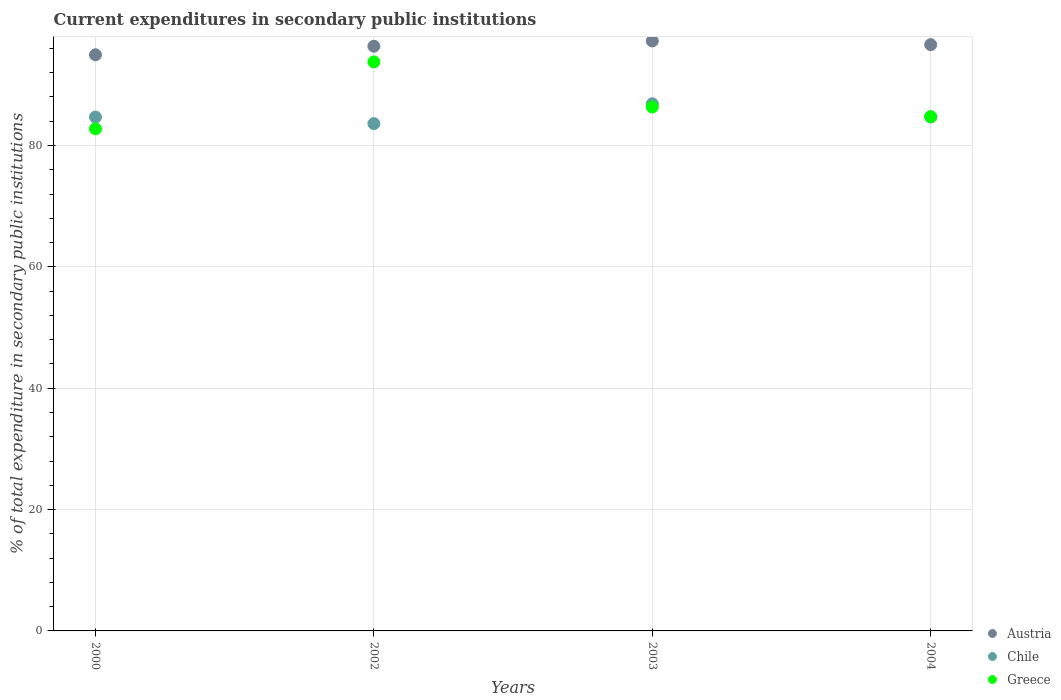Is the number of dotlines equal to the number of legend labels?
Offer a very short reply. Yes. What is the current expenditures in secondary public institutions in Greece in 2004?
Provide a succinct answer. 84.74. Across all years, what is the maximum current expenditures in secondary public institutions in Austria?
Provide a succinct answer. 97.22. Across all years, what is the minimum current expenditures in secondary public institutions in Austria?
Your answer should be compact. 94.94. In which year was the current expenditures in secondary public institutions in Greece maximum?
Your answer should be compact. 2002. In which year was the current expenditures in secondary public institutions in Chile minimum?
Provide a succinct answer. 2002. What is the total current expenditures in secondary public institutions in Greece in the graph?
Provide a succinct answer. 347.6. What is the difference between the current expenditures in secondary public institutions in Greece in 2003 and that in 2004?
Offer a terse response. 1.59. What is the difference between the current expenditures in secondary public institutions in Greece in 2004 and the current expenditures in secondary public institutions in Austria in 2003?
Offer a terse response. -12.48. What is the average current expenditures in secondary public institutions in Greece per year?
Make the answer very short. 86.9. In the year 2004, what is the difference between the current expenditures in secondary public institutions in Austria and current expenditures in secondary public institutions in Greece?
Give a very brief answer. 11.87. What is the ratio of the current expenditures in secondary public institutions in Chile in 2000 to that in 2003?
Your answer should be very brief. 0.97. What is the difference between the highest and the second highest current expenditures in secondary public institutions in Chile?
Ensure brevity in your answer.  2.17. What is the difference between the highest and the lowest current expenditures in secondary public institutions in Greece?
Ensure brevity in your answer.  11.03. Is the sum of the current expenditures in secondary public institutions in Austria in 2003 and 2004 greater than the maximum current expenditures in secondary public institutions in Chile across all years?
Provide a succinct answer. Yes. Does the current expenditures in secondary public institutions in Greece monotonically increase over the years?
Provide a succinct answer. No. Is the current expenditures in secondary public institutions in Chile strictly greater than the current expenditures in secondary public institutions in Greece over the years?
Provide a succinct answer. No. Is the current expenditures in secondary public institutions in Chile strictly less than the current expenditures in secondary public institutions in Greece over the years?
Offer a very short reply. No. How many dotlines are there?
Provide a succinct answer. 3. How many years are there in the graph?
Keep it short and to the point. 4. What is the difference between two consecutive major ticks on the Y-axis?
Provide a succinct answer. 20. Does the graph contain any zero values?
Provide a short and direct response. No. Does the graph contain grids?
Offer a very short reply. Yes. How many legend labels are there?
Ensure brevity in your answer.  3. What is the title of the graph?
Offer a very short reply. Current expenditures in secondary public institutions. What is the label or title of the X-axis?
Provide a short and direct response. Years. What is the label or title of the Y-axis?
Offer a very short reply. % of total expenditure in secondary public institutions. What is the % of total expenditure in secondary public institutions in Austria in 2000?
Your answer should be compact. 94.94. What is the % of total expenditure in secondary public institutions in Chile in 2000?
Offer a very short reply. 84.67. What is the % of total expenditure in secondary public institutions of Greece in 2000?
Your answer should be compact. 82.75. What is the % of total expenditure in secondary public institutions in Austria in 2002?
Your answer should be very brief. 96.35. What is the % of total expenditure in secondary public institutions in Chile in 2002?
Make the answer very short. 83.6. What is the % of total expenditure in secondary public institutions of Greece in 2002?
Give a very brief answer. 93.77. What is the % of total expenditure in secondary public institutions of Austria in 2003?
Offer a very short reply. 97.22. What is the % of total expenditure in secondary public institutions of Chile in 2003?
Offer a terse response. 86.87. What is the % of total expenditure in secondary public institutions of Greece in 2003?
Ensure brevity in your answer.  86.33. What is the % of total expenditure in secondary public institutions of Austria in 2004?
Ensure brevity in your answer.  96.61. What is the % of total expenditure in secondary public institutions in Chile in 2004?
Provide a succinct answer. 84.69. What is the % of total expenditure in secondary public institutions in Greece in 2004?
Your answer should be very brief. 84.74. Across all years, what is the maximum % of total expenditure in secondary public institutions of Austria?
Ensure brevity in your answer.  97.22. Across all years, what is the maximum % of total expenditure in secondary public institutions of Chile?
Offer a very short reply. 86.87. Across all years, what is the maximum % of total expenditure in secondary public institutions of Greece?
Your response must be concise. 93.77. Across all years, what is the minimum % of total expenditure in secondary public institutions of Austria?
Your answer should be compact. 94.94. Across all years, what is the minimum % of total expenditure in secondary public institutions in Chile?
Offer a terse response. 83.6. Across all years, what is the minimum % of total expenditure in secondary public institutions in Greece?
Keep it short and to the point. 82.75. What is the total % of total expenditure in secondary public institutions in Austria in the graph?
Provide a short and direct response. 385.13. What is the total % of total expenditure in secondary public institutions of Chile in the graph?
Offer a terse response. 339.84. What is the total % of total expenditure in secondary public institutions in Greece in the graph?
Your response must be concise. 347.6. What is the difference between the % of total expenditure in secondary public institutions in Austria in 2000 and that in 2002?
Provide a succinct answer. -1.41. What is the difference between the % of total expenditure in secondary public institutions of Chile in 2000 and that in 2002?
Give a very brief answer. 1.07. What is the difference between the % of total expenditure in secondary public institutions of Greece in 2000 and that in 2002?
Provide a short and direct response. -11.03. What is the difference between the % of total expenditure in secondary public institutions of Austria in 2000 and that in 2003?
Provide a short and direct response. -2.28. What is the difference between the % of total expenditure in secondary public institutions in Chile in 2000 and that in 2003?
Make the answer very short. -2.2. What is the difference between the % of total expenditure in secondary public institutions in Greece in 2000 and that in 2003?
Your response must be concise. -3.58. What is the difference between the % of total expenditure in secondary public institutions in Austria in 2000 and that in 2004?
Ensure brevity in your answer.  -1.67. What is the difference between the % of total expenditure in secondary public institutions in Chile in 2000 and that in 2004?
Offer a very short reply. -0.02. What is the difference between the % of total expenditure in secondary public institutions in Greece in 2000 and that in 2004?
Make the answer very short. -1.99. What is the difference between the % of total expenditure in secondary public institutions in Austria in 2002 and that in 2003?
Provide a short and direct response. -0.87. What is the difference between the % of total expenditure in secondary public institutions of Chile in 2002 and that in 2003?
Make the answer very short. -3.27. What is the difference between the % of total expenditure in secondary public institutions of Greece in 2002 and that in 2003?
Offer a terse response. 7.44. What is the difference between the % of total expenditure in secondary public institutions in Austria in 2002 and that in 2004?
Keep it short and to the point. -0.26. What is the difference between the % of total expenditure in secondary public institutions of Chile in 2002 and that in 2004?
Your answer should be very brief. -1.09. What is the difference between the % of total expenditure in secondary public institutions of Greece in 2002 and that in 2004?
Ensure brevity in your answer.  9.03. What is the difference between the % of total expenditure in secondary public institutions of Austria in 2003 and that in 2004?
Offer a terse response. 0.61. What is the difference between the % of total expenditure in secondary public institutions of Chile in 2003 and that in 2004?
Keep it short and to the point. 2.17. What is the difference between the % of total expenditure in secondary public institutions of Greece in 2003 and that in 2004?
Ensure brevity in your answer.  1.59. What is the difference between the % of total expenditure in secondary public institutions of Austria in 2000 and the % of total expenditure in secondary public institutions of Chile in 2002?
Offer a very short reply. 11.34. What is the difference between the % of total expenditure in secondary public institutions in Austria in 2000 and the % of total expenditure in secondary public institutions in Greece in 2002?
Your answer should be very brief. 1.17. What is the difference between the % of total expenditure in secondary public institutions in Chile in 2000 and the % of total expenditure in secondary public institutions in Greece in 2002?
Ensure brevity in your answer.  -9.1. What is the difference between the % of total expenditure in secondary public institutions in Austria in 2000 and the % of total expenditure in secondary public institutions in Chile in 2003?
Provide a short and direct response. 8.07. What is the difference between the % of total expenditure in secondary public institutions in Austria in 2000 and the % of total expenditure in secondary public institutions in Greece in 2003?
Ensure brevity in your answer.  8.61. What is the difference between the % of total expenditure in secondary public institutions in Chile in 2000 and the % of total expenditure in secondary public institutions in Greece in 2003?
Provide a succinct answer. -1.66. What is the difference between the % of total expenditure in secondary public institutions of Austria in 2000 and the % of total expenditure in secondary public institutions of Chile in 2004?
Offer a very short reply. 10.25. What is the difference between the % of total expenditure in secondary public institutions in Austria in 2000 and the % of total expenditure in secondary public institutions in Greece in 2004?
Offer a very short reply. 10.2. What is the difference between the % of total expenditure in secondary public institutions in Chile in 2000 and the % of total expenditure in secondary public institutions in Greece in 2004?
Give a very brief answer. -0.07. What is the difference between the % of total expenditure in secondary public institutions of Austria in 2002 and the % of total expenditure in secondary public institutions of Chile in 2003?
Give a very brief answer. 9.48. What is the difference between the % of total expenditure in secondary public institutions of Austria in 2002 and the % of total expenditure in secondary public institutions of Greece in 2003?
Make the answer very short. 10.02. What is the difference between the % of total expenditure in secondary public institutions of Chile in 2002 and the % of total expenditure in secondary public institutions of Greece in 2003?
Provide a short and direct response. -2.73. What is the difference between the % of total expenditure in secondary public institutions of Austria in 2002 and the % of total expenditure in secondary public institutions of Chile in 2004?
Your answer should be very brief. 11.66. What is the difference between the % of total expenditure in secondary public institutions of Austria in 2002 and the % of total expenditure in secondary public institutions of Greece in 2004?
Provide a succinct answer. 11.61. What is the difference between the % of total expenditure in secondary public institutions in Chile in 2002 and the % of total expenditure in secondary public institutions in Greece in 2004?
Provide a short and direct response. -1.14. What is the difference between the % of total expenditure in secondary public institutions in Austria in 2003 and the % of total expenditure in secondary public institutions in Chile in 2004?
Offer a very short reply. 12.53. What is the difference between the % of total expenditure in secondary public institutions in Austria in 2003 and the % of total expenditure in secondary public institutions in Greece in 2004?
Your answer should be very brief. 12.48. What is the difference between the % of total expenditure in secondary public institutions of Chile in 2003 and the % of total expenditure in secondary public institutions of Greece in 2004?
Your response must be concise. 2.13. What is the average % of total expenditure in secondary public institutions in Austria per year?
Offer a terse response. 96.28. What is the average % of total expenditure in secondary public institutions in Chile per year?
Provide a short and direct response. 84.96. What is the average % of total expenditure in secondary public institutions in Greece per year?
Your answer should be very brief. 86.9. In the year 2000, what is the difference between the % of total expenditure in secondary public institutions of Austria and % of total expenditure in secondary public institutions of Chile?
Offer a terse response. 10.27. In the year 2000, what is the difference between the % of total expenditure in secondary public institutions of Austria and % of total expenditure in secondary public institutions of Greece?
Provide a short and direct response. 12.19. In the year 2000, what is the difference between the % of total expenditure in secondary public institutions of Chile and % of total expenditure in secondary public institutions of Greece?
Provide a succinct answer. 1.93. In the year 2002, what is the difference between the % of total expenditure in secondary public institutions in Austria and % of total expenditure in secondary public institutions in Chile?
Keep it short and to the point. 12.75. In the year 2002, what is the difference between the % of total expenditure in secondary public institutions in Austria and % of total expenditure in secondary public institutions in Greece?
Make the answer very short. 2.58. In the year 2002, what is the difference between the % of total expenditure in secondary public institutions in Chile and % of total expenditure in secondary public institutions in Greece?
Your answer should be compact. -10.17. In the year 2003, what is the difference between the % of total expenditure in secondary public institutions of Austria and % of total expenditure in secondary public institutions of Chile?
Your answer should be very brief. 10.35. In the year 2003, what is the difference between the % of total expenditure in secondary public institutions in Austria and % of total expenditure in secondary public institutions in Greece?
Provide a succinct answer. 10.89. In the year 2003, what is the difference between the % of total expenditure in secondary public institutions of Chile and % of total expenditure in secondary public institutions of Greece?
Give a very brief answer. 0.54. In the year 2004, what is the difference between the % of total expenditure in secondary public institutions in Austria and % of total expenditure in secondary public institutions in Chile?
Ensure brevity in your answer.  11.92. In the year 2004, what is the difference between the % of total expenditure in secondary public institutions in Austria and % of total expenditure in secondary public institutions in Greece?
Provide a short and direct response. 11.87. In the year 2004, what is the difference between the % of total expenditure in secondary public institutions of Chile and % of total expenditure in secondary public institutions of Greece?
Your answer should be very brief. -0.05. What is the ratio of the % of total expenditure in secondary public institutions in Austria in 2000 to that in 2002?
Keep it short and to the point. 0.99. What is the ratio of the % of total expenditure in secondary public institutions of Chile in 2000 to that in 2002?
Ensure brevity in your answer.  1.01. What is the ratio of the % of total expenditure in secondary public institutions of Greece in 2000 to that in 2002?
Provide a short and direct response. 0.88. What is the ratio of the % of total expenditure in secondary public institutions of Austria in 2000 to that in 2003?
Ensure brevity in your answer.  0.98. What is the ratio of the % of total expenditure in secondary public institutions of Chile in 2000 to that in 2003?
Your answer should be compact. 0.97. What is the ratio of the % of total expenditure in secondary public institutions of Greece in 2000 to that in 2003?
Give a very brief answer. 0.96. What is the ratio of the % of total expenditure in secondary public institutions in Austria in 2000 to that in 2004?
Your answer should be compact. 0.98. What is the ratio of the % of total expenditure in secondary public institutions in Chile in 2000 to that in 2004?
Your answer should be compact. 1. What is the ratio of the % of total expenditure in secondary public institutions of Greece in 2000 to that in 2004?
Your answer should be compact. 0.98. What is the ratio of the % of total expenditure in secondary public institutions in Chile in 2002 to that in 2003?
Keep it short and to the point. 0.96. What is the ratio of the % of total expenditure in secondary public institutions of Greece in 2002 to that in 2003?
Your answer should be very brief. 1.09. What is the ratio of the % of total expenditure in secondary public institutions in Austria in 2002 to that in 2004?
Offer a terse response. 1. What is the ratio of the % of total expenditure in secondary public institutions of Chile in 2002 to that in 2004?
Provide a succinct answer. 0.99. What is the ratio of the % of total expenditure in secondary public institutions of Greece in 2002 to that in 2004?
Provide a succinct answer. 1.11. What is the ratio of the % of total expenditure in secondary public institutions in Austria in 2003 to that in 2004?
Offer a terse response. 1.01. What is the ratio of the % of total expenditure in secondary public institutions of Chile in 2003 to that in 2004?
Offer a very short reply. 1.03. What is the ratio of the % of total expenditure in secondary public institutions of Greece in 2003 to that in 2004?
Offer a terse response. 1.02. What is the difference between the highest and the second highest % of total expenditure in secondary public institutions of Austria?
Make the answer very short. 0.61. What is the difference between the highest and the second highest % of total expenditure in secondary public institutions in Chile?
Give a very brief answer. 2.17. What is the difference between the highest and the second highest % of total expenditure in secondary public institutions in Greece?
Provide a short and direct response. 7.44. What is the difference between the highest and the lowest % of total expenditure in secondary public institutions in Austria?
Provide a succinct answer. 2.28. What is the difference between the highest and the lowest % of total expenditure in secondary public institutions in Chile?
Your answer should be very brief. 3.27. What is the difference between the highest and the lowest % of total expenditure in secondary public institutions in Greece?
Your response must be concise. 11.03. 